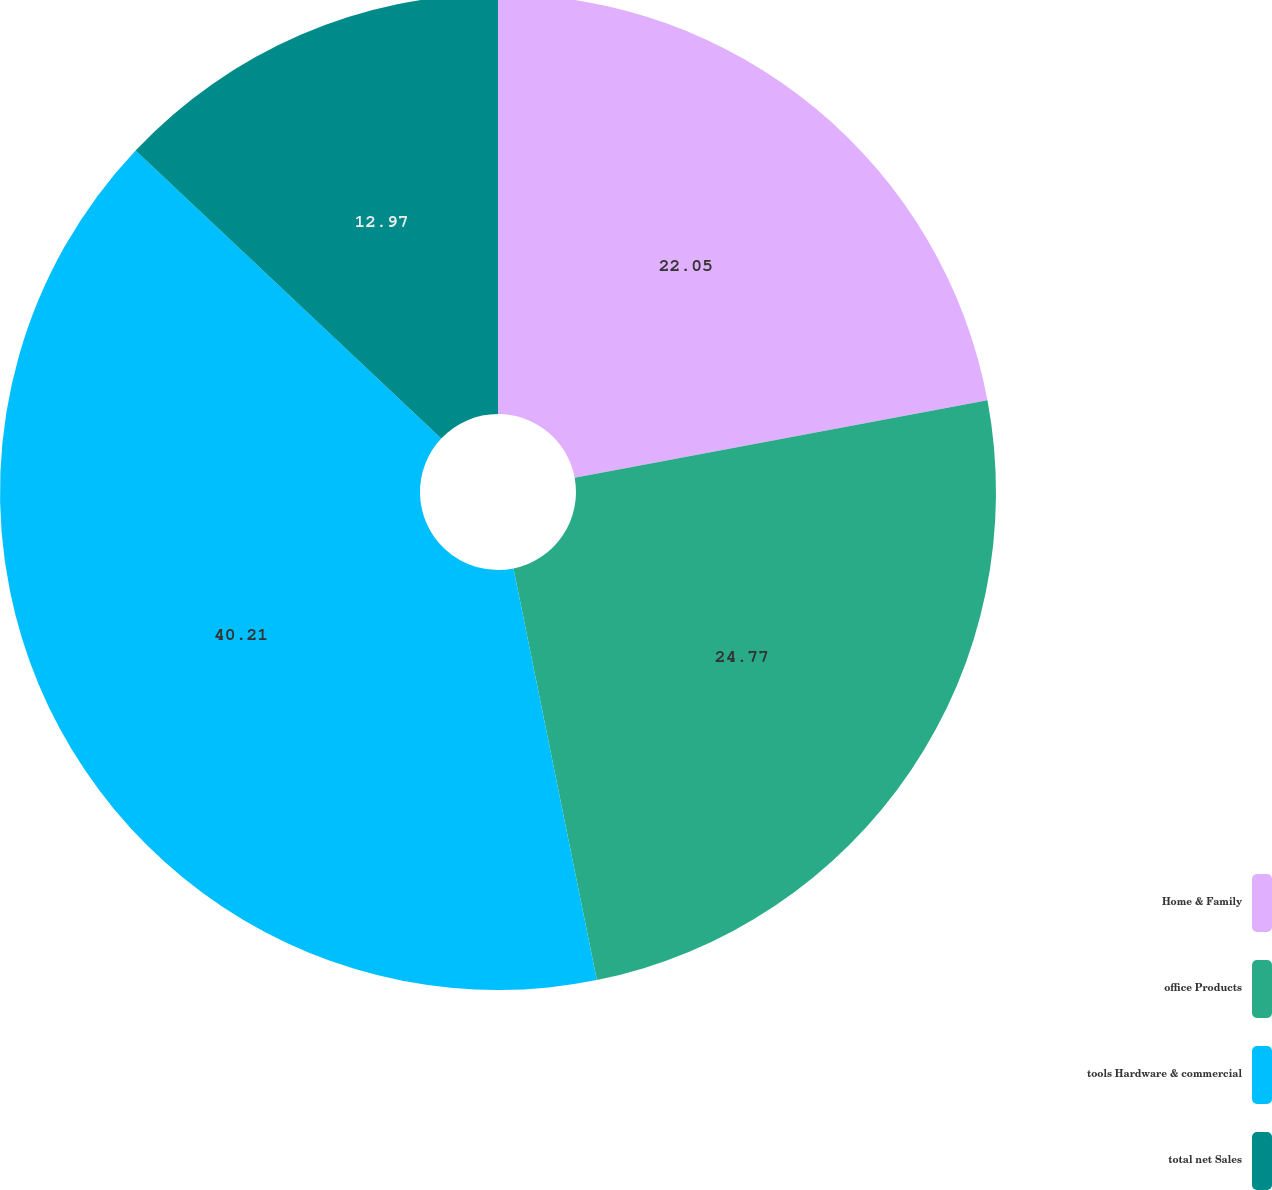Convert chart to OTSL. <chart><loc_0><loc_0><loc_500><loc_500><pie_chart><fcel>Home & Family<fcel>office Products<fcel>tools Hardware & commercial<fcel>total net Sales<nl><fcel>22.05%<fcel>24.77%<fcel>40.21%<fcel>12.97%<nl></chart> 